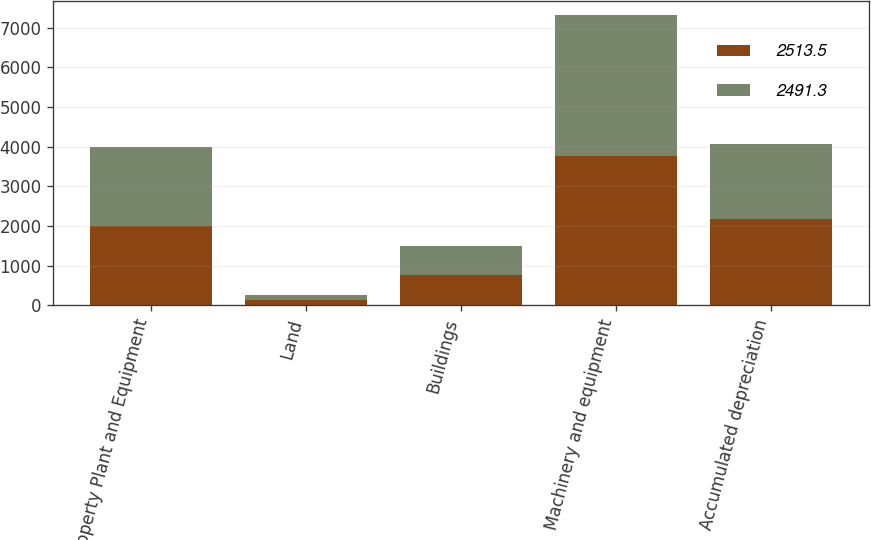Convert chart. <chart><loc_0><loc_0><loc_500><loc_500><stacked_bar_chart><ecel><fcel>Property Plant and Equipment<fcel>Land<fcel>Buildings<fcel>Machinery and equipment<fcel>Accumulated depreciation<nl><fcel>2513.5<fcel>2002<fcel>132.7<fcel>771.8<fcel>3752.4<fcel>2165.6<nl><fcel>2491.3<fcel>2001<fcel>128.8<fcel>726.7<fcel>3553.4<fcel>1895.4<nl></chart> 